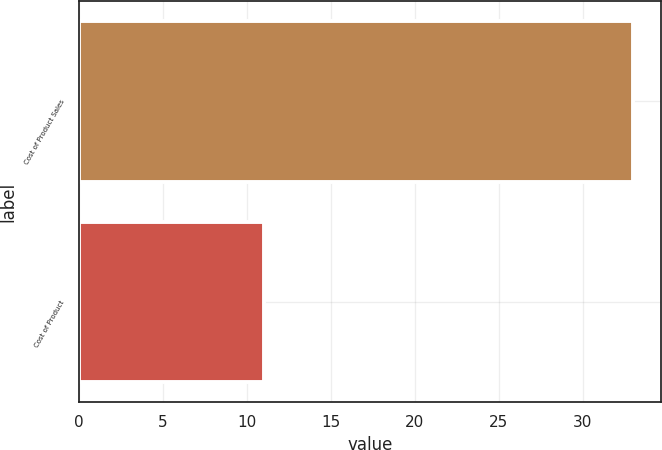Convert chart. <chart><loc_0><loc_0><loc_500><loc_500><bar_chart><fcel>Cost of Product Sales<fcel>Cost of Product<nl><fcel>33<fcel>11<nl></chart> 